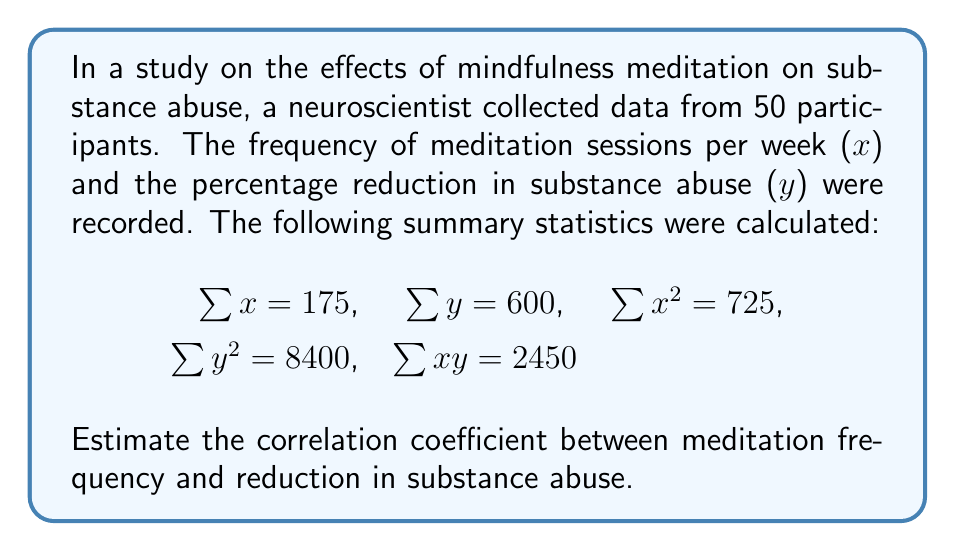Can you answer this question? To estimate the correlation coefficient, we'll use the Pearson correlation formula:

$$r = \frac{n\sum xy - \sum x \sum y}{\sqrt{[n\sum x^2 - (\sum x)^2][n\sum y^2 - (\sum y)^2]}}$$

Where $n$ is the number of participants.

Step 1: Calculate $n\sum xy$
$n\sum xy = 50 \times 2450 = 122500$

Step 2: Calculate $\sum x \sum y$
$\sum x \sum y = 175 \times 600 = 105000$

Step 3: Calculate the numerator
$n\sum xy - \sum x \sum y = 122500 - 105000 = 17500$

Step 4: Calculate $n\sum x^2$ and $(\sum x)^2$
$n\sum x^2 = 50 \times 725 = 36250$
$(\sum x)^2 = 175^2 = 30625$

Step 5: Calculate $n\sum y^2$ and $(\sum y)^2$
$n\sum y^2 = 50 \times 8400 = 420000$
$(\sum y)^2 = 600^2 = 360000$

Step 6: Calculate the denominator
$\sqrt{[n\sum x^2 - (\sum x)^2][n\sum y^2 - (\sum y)^2]}$
$= \sqrt{(36250 - 30625)(420000 - 360000)}$
$= \sqrt{5625 \times 60000}$
$= \sqrt{337500000}$
$= 18371.17$ (rounded to 2 decimal places)

Step 7: Calculate the correlation coefficient
$r = \frac{17500}{18371.17} \approx 0.9525$
Answer: $r \approx 0.9525$ 